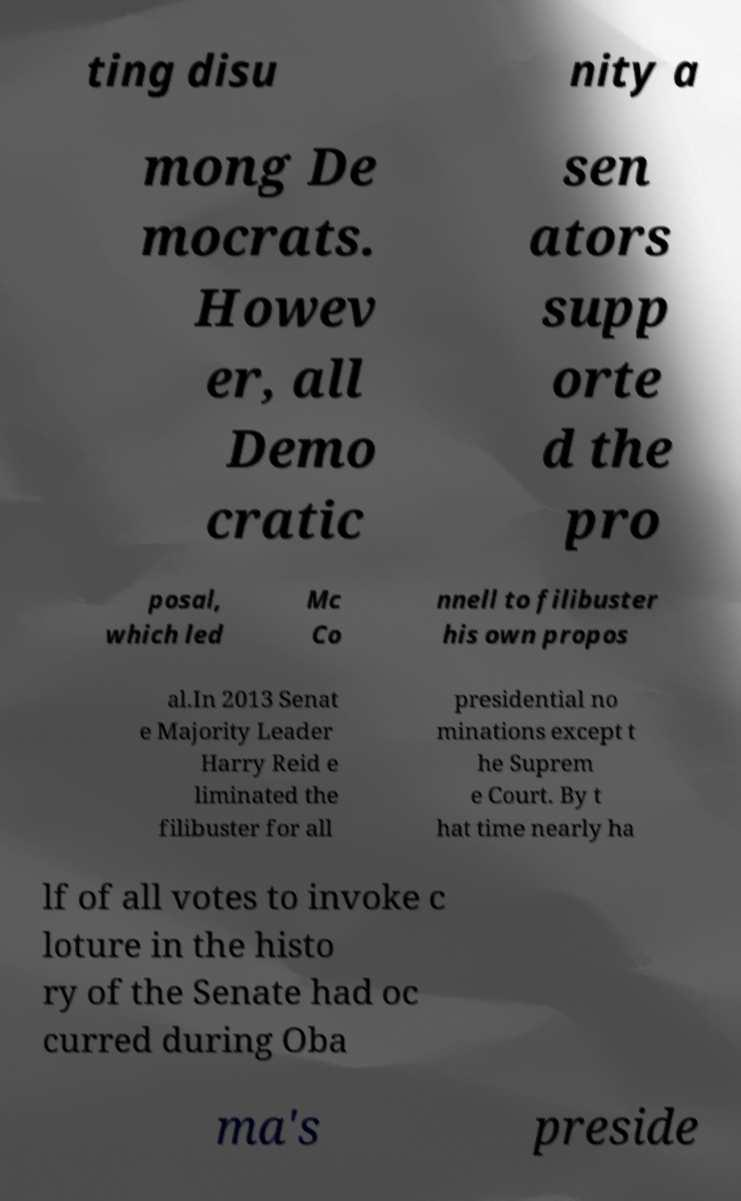Please read and relay the text visible in this image. What does it say? ting disu nity a mong De mocrats. Howev er, all Demo cratic sen ators supp orte d the pro posal, which led Mc Co nnell to filibuster his own propos al.In 2013 Senat e Majority Leader Harry Reid e liminated the filibuster for all presidential no minations except t he Suprem e Court. By t hat time nearly ha lf of all votes to invoke c loture in the histo ry of the Senate had oc curred during Oba ma's preside 